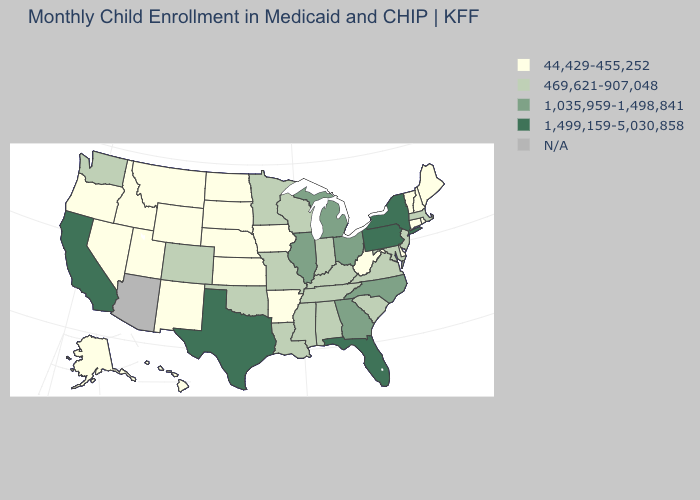Name the states that have a value in the range 44,429-455,252?
Write a very short answer. Alaska, Arkansas, Connecticut, Delaware, Hawaii, Idaho, Iowa, Kansas, Maine, Montana, Nebraska, Nevada, New Hampshire, New Mexico, North Dakota, Oregon, Rhode Island, South Dakota, Utah, Vermont, West Virginia, Wyoming. Which states have the lowest value in the USA?
Give a very brief answer. Alaska, Arkansas, Connecticut, Delaware, Hawaii, Idaho, Iowa, Kansas, Maine, Montana, Nebraska, Nevada, New Hampshire, New Mexico, North Dakota, Oregon, Rhode Island, South Dakota, Utah, Vermont, West Virginia, Wyoming. What is the value of Oregon?
Keep it brief. 44,429-455,252. Name the states that have a value in the range 469,621-907,048?
Concise answer only. Alabama, Colorado, Indiana, Kentucky, Louisiana, Maryland, Massachusetts, Minnesota, Mississippi, Missouri, New Jersey, Oklahoma, South Carolina, Tennessee, Virginia, Washington, Wisconsin. What is the value of Florida?
Give a very brief answer. 1,499,159-5,030,858. What is the value of Tennessee?
Write a very short answer. 469,621-907,048. Does Georgia have the lowest value in the South?
Answer briefly. No. Does the first symbol in the legend represent the smallest category?
Write a very short answer. Yes. Name the states that have a value in the range 1,499,159-5,030,858?
Quick response, please. California, Florida, New York, Pennsylvania, Texas. Name the states that have a value in the range 44,429-455,252?
Write a very short answer. Alaska, Arkansas, Connecticut, Delaware, Hawaii, Idaho, Iowa, Kansas, Maine, Montana, Nebraska, Nevada, New Hampshire, New Mexico, North Dakota, Oregon, Rhode Island, South Dakota, Utah, Vermont, West Virginia, Wyoming. Does the map have missing data?
Keep it brief. Yes. Which states have the highest value in the USA?
Write a very short answer. California, Florida, New York, Pennsylvania, Texas. Name the states that have a value in the range 469,621-907,048?
Short answer required. Alabama, Colorado, Indiana, Kentucky, Louisiana, Maryland, Massachusetts, Minnesota, Mississippi, Missouri, New Jersey, Oklahoma, South Carolina, Tennessee, Virginia, Washington, Wisconsin. How many symbols are there in the legend?
Give a very brief answer. 5. What is the lowest value in the Northeast?
Concise answer only. 44,429-455,252. 